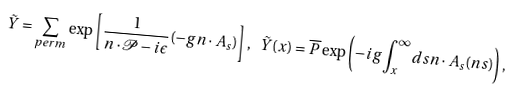<formula> <loc_0><loc_0><loc_500><loc_500>\tilde { Y } = \sum _ { p e r m } \exp \left [ \frac { 1 } { n \cdot \mathcal { P } - i \epsilon } ( - g n \cdot A _ { s } ) \right ] , \ \tilde { Y } ( x ) = \overline { P } \exp \left ( - i g \int _ { x } ^ { \infty } d s n \cdot A _ { s } ( n s ) \right ) ,</formula> 